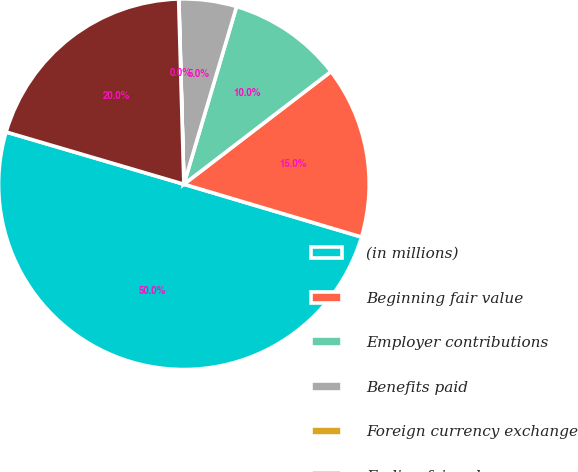Convert chart. <chart><loc_0><loc_0><loc_500><loc_500><pie_chart><fcel>(in millions)<fcel>Beginning fair value<fcel>Employer contributions<fcel>Benefits paid<fcel>Foreign currency exchange<fcel>Ending fair value<nl><fcel>49.95%<fcel>15.0%<fcel>10.01%<fcel>5.02%<fcel>0.02%<fcel>20.0%<nl></chart> 